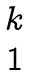Convert formula to latex. <formula><loc_0><loc_0><loc_500><loc_500>\begin{matrix} k \\ 1 \end{matrix}</formula> 